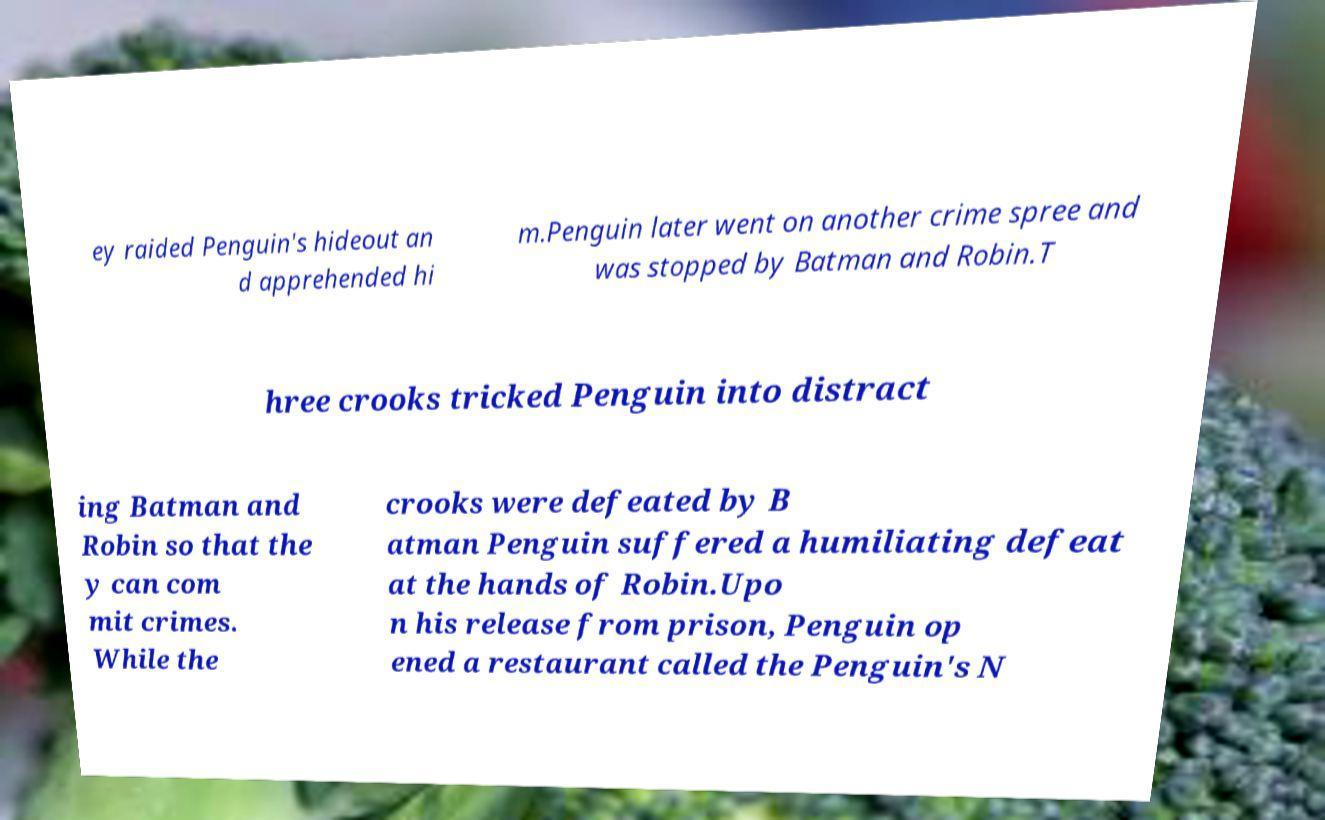Could you assist in decoding the text presented in this image and type it out clearly? ey raided Penguin's hideout an d apprehended hi m.Penguin later went on another crime spree and was stopped by Batman and Robin.T hree crooks tricked Penguin into distract ing Batman and Robin so that the y can com mit crimes. While the crooks were defeated by B atman Penguin suffered a humiliating defeat at the hands of Robin.Upo n his release from prison, Penguin op ened a restaurant called the Penguin's N 